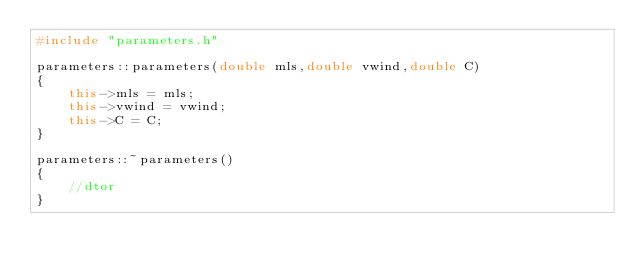<code> <loc_0><loc_0><loc_500><loc_500><_C++_>#include "parameters.h"

parameters::parameters(double mls,double vwind,double C)
{
    this->mls = mls;
    this->vwind = vwind;
    this->C = C;
}

parameters::~parameters()
{
    //dtor
}
</code> 